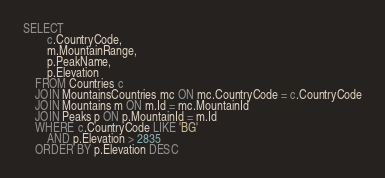<code> <loc_0><loc_0><loc_500><loc_500><_SQL_>SELECT 
		c.CountryCode, 
		m.MountainRange,
		p.PeakName, 
		p.Elevation
	FROM Countries c
	JOIN MountainsCountries mc ON mc.CountryCode = c.CountryCode
	JOIN Mountains m ON m.Id = mc.MountainId
	JOIN Peaks p ON p.MountainId = m.Id
	WHERE c.CountryCode LIKE 'BG' 
		AND p.Elevation > 2835
	ORDER BY p.Elevation DESC





</code> 